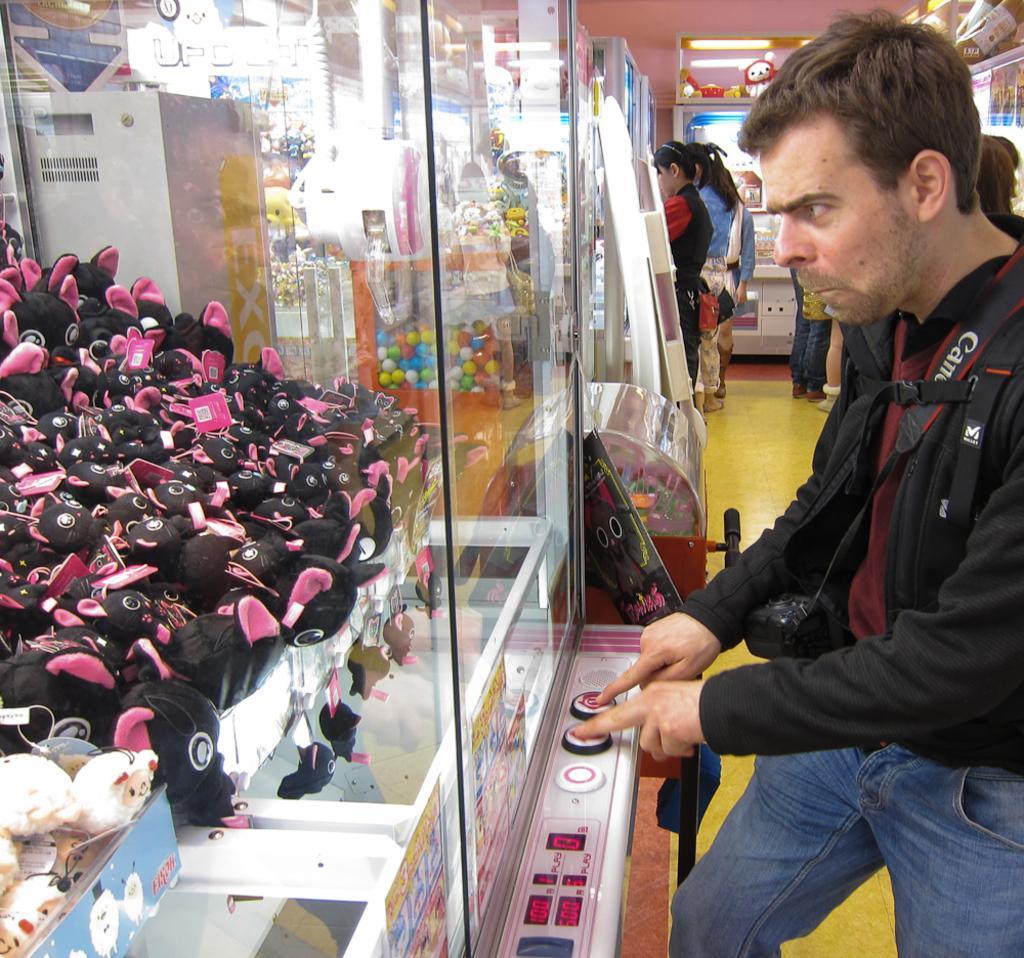Could you give a brief overview of what you see in this image? In this image there are toys in the glass boxes , there is a person standing and pressing the buttons, and in the background there are toys , group of people standing. 